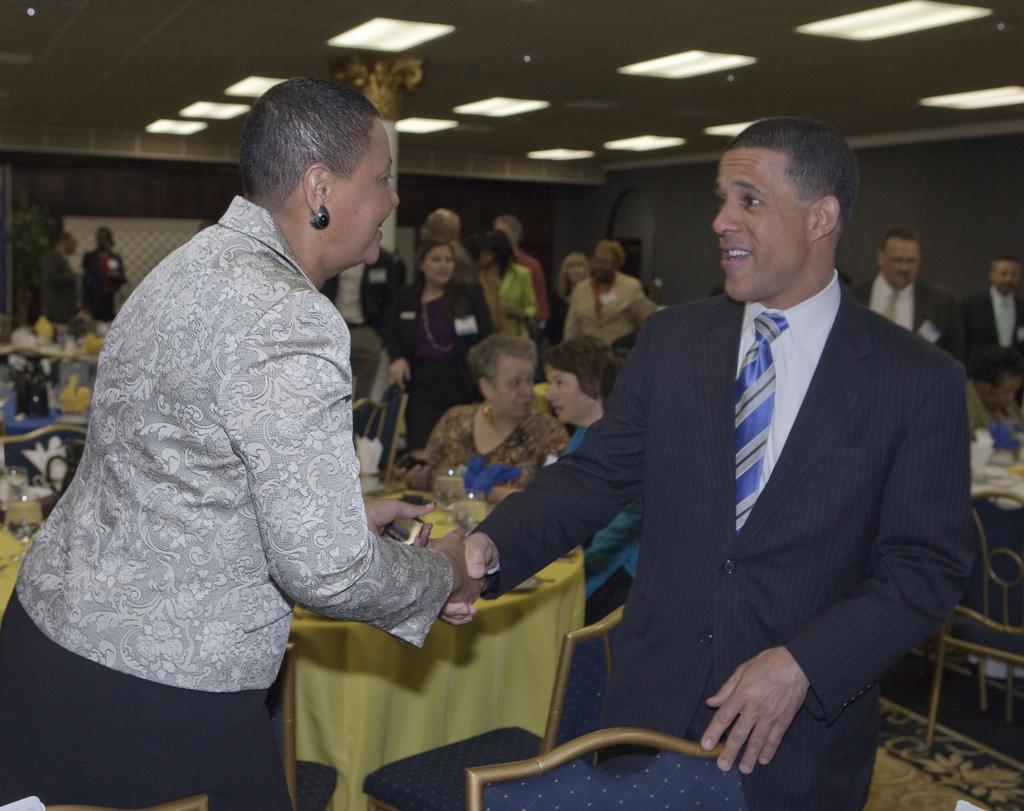How would you summarize this image in a sentence or two? In the foreground of the image there are two people shaking hands. In the background of the image there are many people. There are tables and chairs in the image. At the top of the image there is ceiling with lights. 